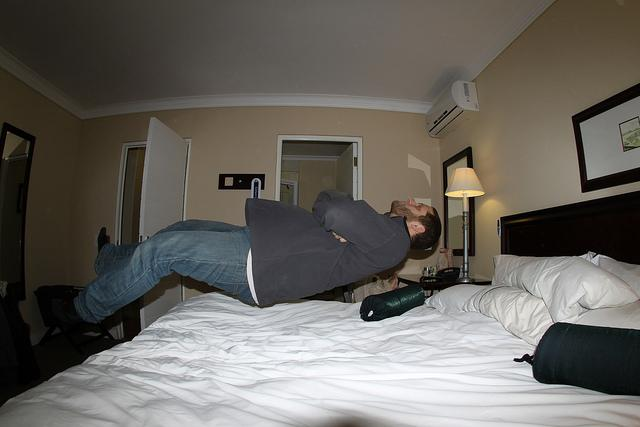The man here is posing to mimic what? levitation 